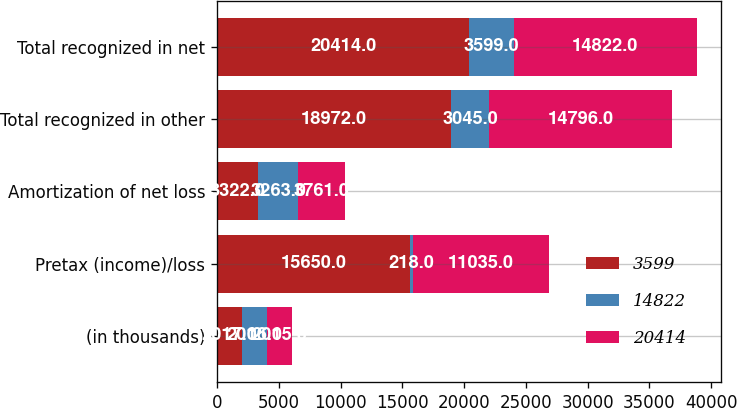Convert chart. <chart><loc_0><loc_0><loc_500><loc_500><stacked_bar_chart><ecel><fcel>(in thousands)<fcel>Pretax (income)/loss<fcel>Amortization of net loss<fcel>Total recognized in other<fcel>Total recognized in net<nl><fcel>3599<fcel>2017<fcel>15650<fcel>3322<fcel>18972<fcel>20414<nl><fcel>14822<fcel>2016<fcel>218<fcel>3263<fcel>3045<fcel>3599<nl><fcel>20414<fcel>2015<fcel>11035<fcel>3761<fcel>14796<fcel>14822<nl></chart> 